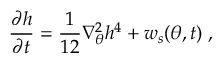Convert formula to latex. <formula><loc_0><loc_0><loc_500><loc_500>\frac { \partial h } { \partial t } = \frac { 1 } { 1 2 } \nabla _ { \theta } ^ { 2 } h ^ { 4 } + w _ { s } ( \theta , t ) \, ,</formula> 